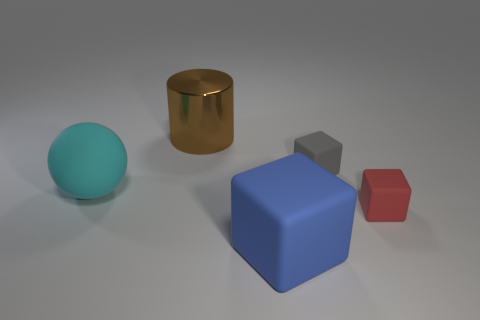Subtract all tiny red rubber cubes. How many cubes are left? 2 Subtract all red cubes. How many cubes are left? 2 Add 2 large shiny cylinders. How many objects exist? 7 Subtract all cubes. How many objects are left? 2 Subtract all big cyan rubber balls. Subtract all shiny objects. How many objects are left? 3 Add 5 small cubes. How many small cubes are left? 7 Add 2 brown cylinders. How many brown cylinders exist? 3 Subtract 0 purple cylinders. How many objects are left? 5 Subtract 1 cylinders. How many cylinders are left? 0 Subtract all gray spheres. Subtract all purple cylinders. How many spheres are left? 1 